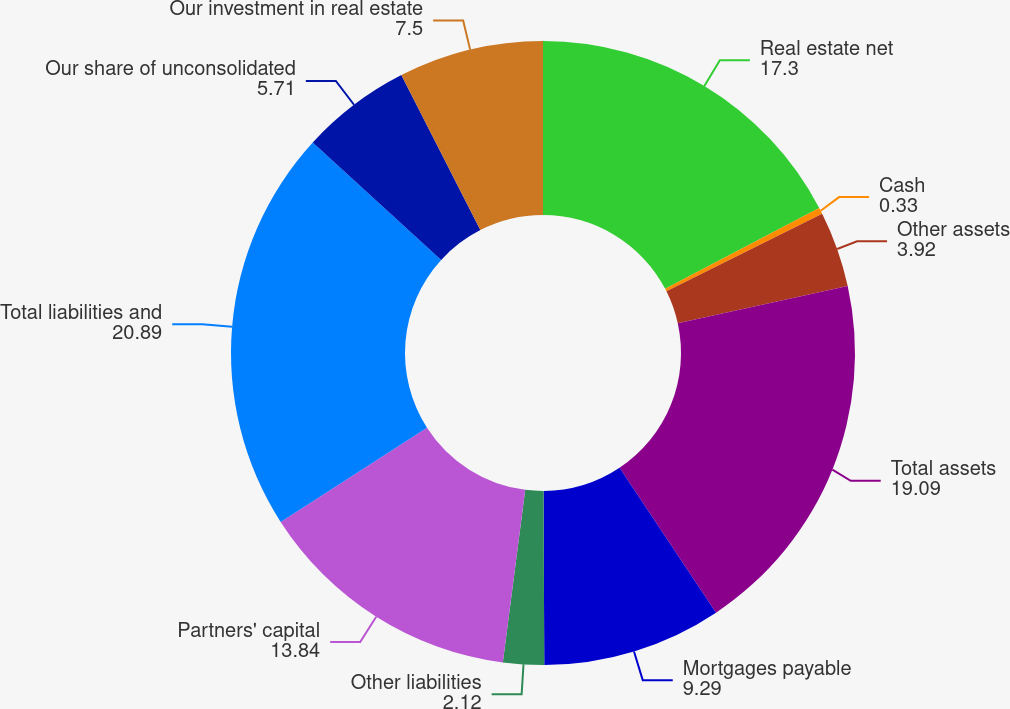Convert chart to OTSL. <chart><loc_0><loc_0><loc_500><loc_500><pie_chart><fcel>Real estate net<fcel>Cash<fcel>Other assets<fcel>Total assets<fcel>Mortgages payable<fcel>Other liabilities<fcel>Partners' capital<fcel>Total liabilities and<fcel>Our share of unconsolidated<fcel>Our investment in real estate<nl><fcel>17.3%<fcel>0.33%<fcel>3.92%<fcel>19.09%<fcel>9.29%<fcel>2.12%<fcel>13.84%<fcel>20.89%<fcel>5.71%<fcel>7.5%<nl></chart> 